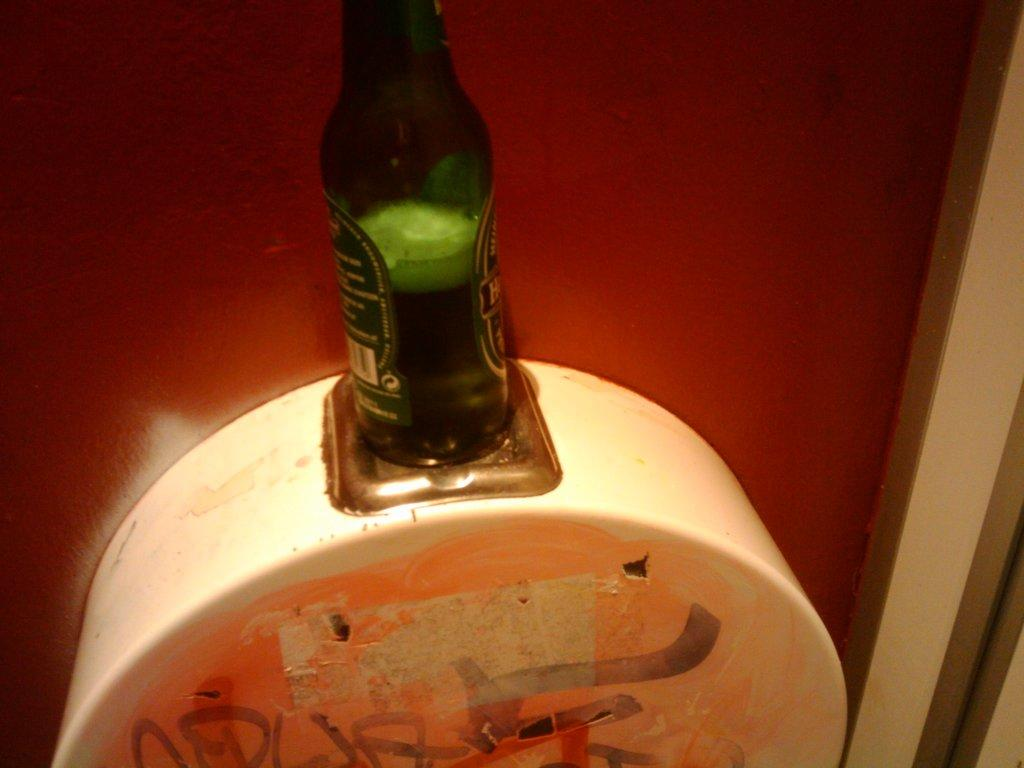What is the color of the beer bottle in the image? The beer bottle in the image is green in color. What is inside the beer bottle? The beer bottle contains alcohol. What can be seen attached to the wall in the image? There is a white color object attached to the wall in the image. What is the color of the background in the image? The background of the image is red in color. What type of trees can be seen in the image? There are no trees present in the image. What is being served for breakfast in the image? There is no breakfast or any food item visible in the image. 